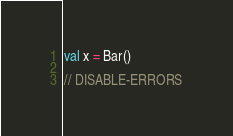Convert code to text. <code><loc_0><loc_0><loc_500><loc_500><_Kotlin_>
val x = Bar()

// DISABLE-ERRORS</code> 